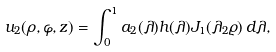<formula> <loc_0><loc_0><loc_500><loc_500>u _ { 2 } ( \rho , \varphi , z ) = \int ^ { 1 } _ { 0 } a _ { 2 } ( \lambda ) h ( \lambda ) J _ { 1 } ( \lambda _ { 2 } \varrho ) \, d \lambda ,</formula> 